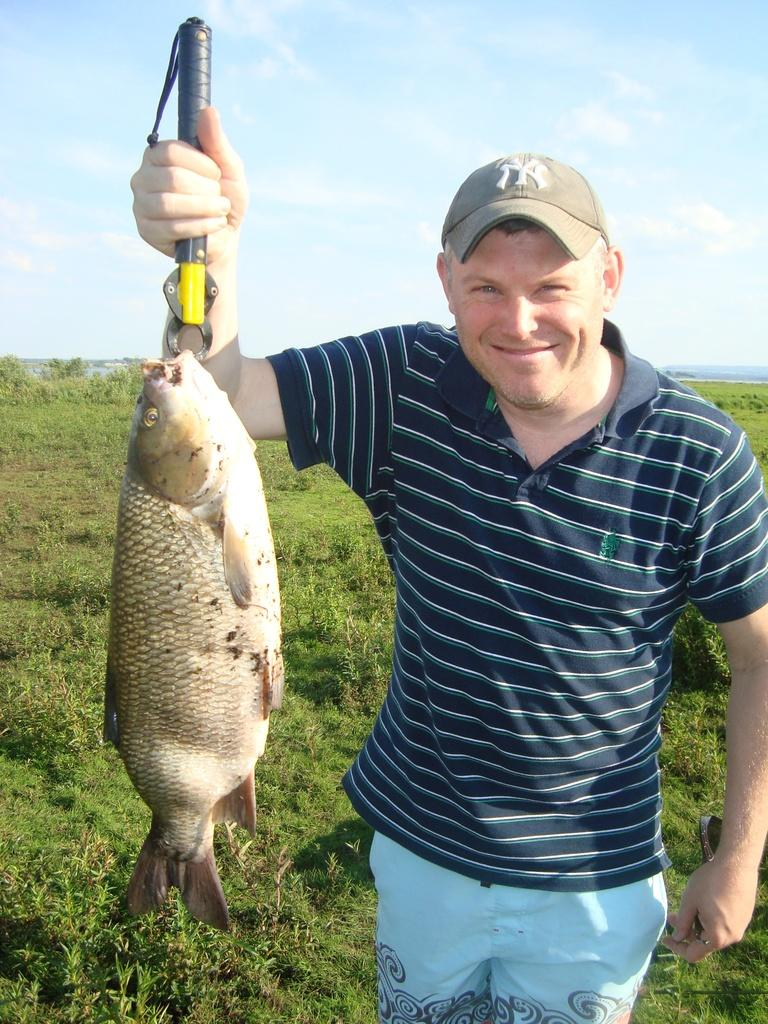What is the main subject of the image? There is a person in the image. What is the person wearing on their head? The person is wearing a cap. What is the person doing in the image? The person is standing and holding a fish with a tool. What can be seen in the background of the image? There is sky visible in the image. What type of vegetation is present on the ground in the image? There are grasses on the ground in the image. What type of fowl can be seen in the person's hobbies in the image? There is no fowl present in the image, and the person's hobbies are not mentioned. 